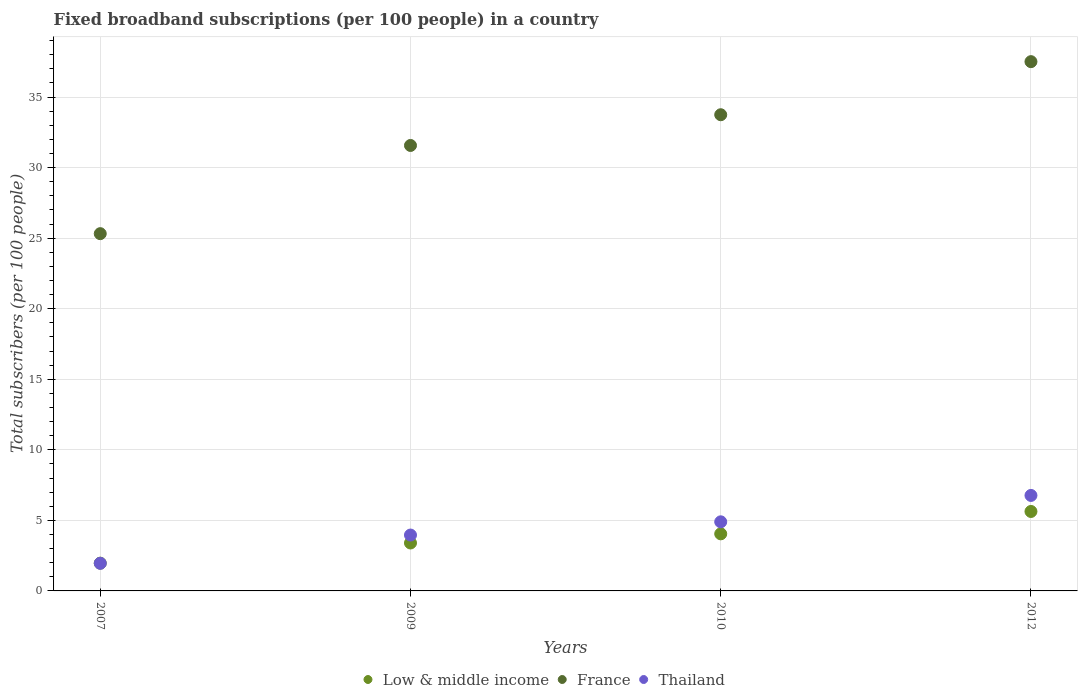What is the number of broadband subscriptions in Low & middle income in 2012?
Make the answer very short. 5.63. Across all years, what is the maximum number of broadband subscriptions in France?
Your response must be concise. 37.51. Across all years, what is the minimum number of broadband subscriptions in Thailand?
Make the answer very short. 1.96. In which year was the number of broadband subscriptions in Thailand maximum?
Keep it short and to the point. 2012. In which year was the number of broadband subscriptions in Low & middle income minimum?
Your response must be concise. 2007. What is the total number of broadband subscriptions in Thailand in the graph?
Make the answer very short. 17.58. What is the difference between the number of broadband subscriptions in Low & middle income in 2007 and that in 2010?
Offer a terse response. -2.08. What is the difference between the number of broadband subscriptions in Thailand in 2009 and the number of broadband subscriptions in France in 2012?
Offer a very short reply. -33.55. What is the average number of broadband subscriptions in Thailand per year?
Give a very brief answer. 4.4. In the year 2010, what is the difference between the number of broadband subscriptions in Thailand and number of broadband subscriptions in Low & middle income?
Provide a short and direct response. 0.85. In how many years, is the number of broadband subscriptions in France greater than 37?
Offer a very short reply. 1. What is the ratio of the number of broadband subscriptions in France in 2007 to that in 2012?
Ensure brevity in your answer.  0.68. Is the difference between the number of broadband subscriptions in Thailand in 2007 and 2009 greater than the difference between the number of broadband subscriptions in Low & middle income in 2007 and 2009?
Ensure brevity in your answer.  No. What is the difference between the highest and the second highest number of broadband subscriptions in France?
Offer a terse response. 3.76. What is the difference between the highest and the lowest number of broadband subscriptions in France?
Ensure brevity in your answer.  12.19. Is the sum of the number of broadband subscriptions in Thailand in 2009 and 2012 greater than the maximum number of broadband subscriptions in Low & middle income across all years?
Offer a terse response. Yes. Is it the case that in every year, the sum of the number of broadband subscriptions in Low & middle income and number of broadband subscriptions in France  is greater than the number of broadband subscriptions in Thailand?
Ensure brevity in your answer.  Yes. Does the number of broadband subscriptions in Low & middle income monotonically increase over the years?
Keep it short and to the point. Yes. Are the values on the major ticks of Y-axis written in scientific E-notation?
Ensure brevity in your answer.  No. Does the graph contain any zero values?
Your response must be concise. No. Does the graph contain grids?
Offer a very short reply. Yes. Where does the legend appear in the graph?
Provide a succinct answer. Bottom center. How are the legend labels stacked?
Provide a short and direct response. Horizontal. What is the title of the graph?
Ensure brevity in your answer.  Fixed broadband subscriptions (per 100 people) in a country. Does "Cote d'Ivoire" appear as one of the legend labels in the graph?
Provide a short and direct response. No. What is the label or title of the X-axis?
Offer a terse response. Years. What is the label or title of the Y-axis?
Offer a very short reply. Total subscribers (per 100 people). What is the Total subscribers (per 100 people) of Low & middle income in 2007?
Your answer should be compact. 1.97. What is the Total subscribers (per 100 people) in France in 2007?
Offer a very short reply. 25.32. What is the Total subscribers (per 100 people) of Thailand in 2007?
Provide a succinct answer. 1.96. What is the Total subscribers (per 100 people) of Low & middle income in 2009?
Give a very brief answer. 3.4. What is the Total subscribers (per 100 people) of France in 2009?
Give a very brief answer. 31.57. What is the Total subscribers (per 100 people) of Thailand in 2009?
Provide a short and direct response. 3.96. What is the Total subscribers (per 100 people) of Low & middle income in 2010?
Provide a succinct answer. 4.05. What is the Total subscribers (per 100 people) of France in 2010?
Provide a short and direct response. 33.74. What is the Total subscribers (per 100 people) in Thailand in 2010?
Make the answer very short. 4.9. What is the Total subscribers (per 100 people) of Low & middle income in 2012?
Your answer should be compact. 5.63. What is the Total subscribers (per 100 people) of France in 2012?
Keep it short and to the point. 37.51. What is the Total subscribers (per 100 people) in Thailand in 2012?
Your answer should be compact. 6.77. Across all years, what is the maximum Total subscribers (per 100 people) of Low & middle income?
Your answer should be compact. 5.63. Across all years, what is the maximum Total subscribers (per 100 people) in France?
Offer a very short reply. 37.51. Across all years, what is the maximum Total subscribers (per 100 people) in Thailand?
Provide a short and direct response. 6.77. Across all years, what is the minimum Total subscribers (per 100 people) of Low & middle income?
Offer a terse response. 1.97. Across all years, what is the minimum Total subscribers (per 100 people) of France?
Keep it short and to the point. 25.32. Across all years, what is the minimum Total subscribers (per 100 people) in Thailand?
Offer a very short reply. 1.96. What is the total Total subscribers (per 100 people) of Low & middle income in the graph?
Make the answer very short. 15.04. What is the total Total subscribers (per 100 people) in France in the graph?
Provide a short and direct response. 128.13. What is the total Total subscribers (per 100 people) in Thailand in the graph?
Your answer should be very brief. 17.58. What is the difference between the Total subscribers (per 100 people) of Low & middle income in 2007 and that in 2009?
Offer a terse response. -1.43. What is the difference between the Total subscribers (per 100 people) in France in 2007 and that in 2009?
Ensure brevity in your answer.  -6.25. What is the difference between the Total subscribers (per 100 people) in Thailand in 2007 and that in 2009?
Keep it short and to the point. -2. What is the difference between the Total subscribers (per 100 people) of Low & middle income in 2007 and that in 2010?
Give a very brief answer. -2.08. What is the difference between the Total subscribers (per 100 people) of France in 2007 and that in 2010?
Give a very brief answer. -8.43. What is the difference between the Total subscribers (per 100 people) of Thailand in 2007 and that in 2010?
Keep it short and to the point. -2.94. What is the difference between the Total subscribers (per 100 people) in Low & middle income in 2007 and that in 2012?
Offer a very short reply. -3.66. What is the difference between the Total subscribers (per 100 people) in France in 2007 and that in 2012?
Ensure brevity in your answer.  -12.19. What is the difference between the Total subscribers (per 100 people) in Thailand in 2007 and that in 2012?
Your answer should be compact. -4.81. What is the difference between the Total subscribers (per 100 people) in Low & middle income in 2009 and that in 2010?
Offer a very short reply. -0.65. What is the difference between the Total subscribers (per 100 people) in France in 2009 and that in 2010?
Provide a short and direct response. -2.18. What is the difference between the Total subscribers (per 100 people) of Thailand in 2009 and that in 2010?
Your answer should be very brief. -0.94. What is the difference between the Total subscribers (per 100 people) in Low & middle income in 2009 and that in 2012?
Keep it short and to the point. -2.23. What is the difference between the Total subscribers (per 100 people) in France in 2009 and that in 2012?
Your answer should be very brief. -5.94. What is the difference between the Total subscribers (per 100 people) of Thailand in 2009 and that in 2012?
Your answer should be very brief. -2.81. What is the difference between the Total subscribers (per 100 people) of Low & middle income in 2010 and that in 2012?
Your answer should be compact. -1.58. What is the difference between the Total subscribers (per 100 people) of France in 2010 and that in 2012?
Your response must be concise. -3.76. What is the difference between the Total subscribers (per 100 people) in Thailand in 2010 and that in 2012?
Provide a short and direct response. -1.87. What is the difference between the Total subscribers (per 100 people) of Low & middle income in 2007 and the Total subscribers (per 100 people) of France in 2009?
Ensure brevity in your answer.  -29.6. What is the difference between the Total subscribers (per 100 people) in Low & middle income in 2007 and the Total subscribers (per 100 people) in Thailand in 2009?
Provide a succinct answer. -1.99. What is the difference between the Total subscribers (per 100 people) of France in 2007 and the Total subscribers (per 100 people) of Thailand in 2009?
Make the answer very short. 21.36. What is the difference between the Total subscribers (per 100 people) of Low & middle income in 2007 and the Total subscribers (per 100 people) of France in 2010?
Your answer should be very brief. -31.78. What is the difference between the Total subscribers (per 100 people) in Low & middle income in 2007 and the Total subscribers (per 100 people) in Thailand in 2010?
Offer a terse response. -2.93. What is the difference between the Total subscribers (per 100 people) in France in 2007 and the Total subscribers (per 100 people) in Thailand in 2010?
Provide a succinct answer. 20.42. What is the difference between the Total subscribers (per 100 people) of Low & middle income in 2007 and the Total subscribers (per 100 people) of France in 2012?
Provide a succinct answer. -35.54. What is the difference between the Total subscribers (per 100 people) of Low & middle income in 2007 and the Total subscribers (per 100 people) of Thailand in 2012?
Offer a very short reply. -4.8. What is the difference between the Total subscribers (per 100 people) of France in 2007 and the Total subscribers (per 100 people) of Thailand in 2012?
Give a very brief answer. 18.55. What is the difference between the Total subscribers (per 100 people) of Low & middle income in 2009 and the Total subscribers (per 100 people) of France in 2010?
Your answer should be compact. -30.35. What is the difference between the Total subscribers (per 100 people) in Low & middle income in 2009 and the Total subscribers (per 100 people) in Thailand in 2010?
Offer a terse response. -1.5. What is the difference between the Total subscribers (per 100 people) of France in 2009 and the Total subscribers (per 100 people) of Thailand in 2010?
Your answer should be compact. 26.67. What is the difference between the Total subscribers (per 100 people) in Low & middle income in 2009 and the Total subscribers (per 100 people) in France in 2012?
Make the answer very short. -34.11. What is the difference between the Total subscribers (per 100 people) of Low & middle income in 2009 and the Total subscribers (per 100 people) of Thailand in 2012?
Make the answer very short. -3.37. What is the difference between the Total subscribers (per 100 people) of France in 2009 and the Total subscribers (per 100 people) of Thailand in 2012?
Keep it short and to the point. 24.8. What is the difference between the Total subscribers (per 100 people) of Low & middle income in 2010 and the Total subscribers (per 100 people) of France in 2012?
Make the answer very short. -33.46. What is the difference between the Total subscribers (per 100 people) of Low & middle income in 2010 and the Total subscribers (per 100 people) of Thailand in 2012?
Keep it short and to the point. -2.72. What is the difference between the Total subscribers (per 100 people) in France in 2010 and the Total subscribers (per 100 people) in Thailand in 2012?
Make the answer very short. 26.98. What is the average Total subscribers (per 100 people) in Low & middle income per year?
Keep it short and to the point. 3.76. What is the average Total subscribers (per 100 people) in France per year?
Ensure brevity in your answer.  32.03. What is the average Total subscribers (per 100 people) of Thailand per year?
Provide a short and direct response. 4.4. In the year 2007, what is the difference between the Total subscribers (per 100 people) of Low & middle income and Total subscribers (per 100 people) of France?
Give a very brief answer. -23.35. In the year 2007, what is the difference between the Total subscribers (per 100 people) of Low & middle income and Total subscribers (per 100 people) of Thailand?
Your response must be concise. 0.01. In the year 2007, what is the difference between the Total subscribers (per 100 people) in France and Total subscribers (per 100 people) in Thailand?
Give a very brief answer. 23.36. In the year 2009, what is the difference between the Total subscribers (per 100 people) in Low & middle income and Total subscribers (per 100 people) in France?
Your response must be concise. -28.17. In the year 2009, what is the difference between the Total subscribers (per 100 people) in Low & middle income and Total subscribers (per 100 people) in Thailand?
Give a very brief answer. -0.56. In the year 2009, what is the difference between the Total subscribers (per 100 people) of France and Total subscribers (per 100 people) of Thailand?
Give a very brief answer. 27.61. In the year 2010, what is the difference between the Total subscribers (per 100 people) of Low & middle income and Total subscribers (per 100 people) of France?
Provide a short and direct response. -29.7. In the year 2010, what is the difference between the Total subscribers (per 100 people) in Low & middle income and Total subscribers (per 100 people) in Thailand?
Offer a terse response. -0.85. In the year 2010, what is the difference between the Total subscribers (per 100 people) of France and Total subscribers (per 100 people) of Thailand?
Your answer should be compact. 28.85. In the year 2012, what is the difference between the Total subscribers (per 100 people) of Low & middle income and Total subscribers (per 100 people) of France?
Ensure brevity in your answer.  -31.88. In the year 2012, what is the difference between the Total subscribers (per 100 people) in Low & middle income and Total subscribers (per 100 people) in Thailand?
Offer a very short reply. -1.14. In the year 2012, what is the difference between the Total subscribers (per 100 people) in France and Total subscribers (per 100 people) in Thailand?
Your answer should be very brief. 30.74. What is the ratio of the Total subscribers (per 100 people) in Low & middle income in 2007 to that in 2009?
Keep it short and to the point. 0.58. What is the ratio of the Total subscribers (per 100 people) in France in 2007 to that in 2009?
Your answer should be compact. 0.8. What is the ratio of the Total subscribers (per 100 people) of Thailand in 2007 to that in 2009?
Your answer should be very brief. 0.49. What is the ratio of the Total subscribers (per 100 people) in Low & middle income in 2007 to that in 2010?
Your answer should be compact. 0.49. What is the ratio of the Total subscribers (per 100 people) of France in 2007 to that in 2010?
Provide a succinct answer. 0.75. What is the ratio of the Total subscribers (per 100 people) in Thailand in 2007 to that in 2010?
Give a very brief answer. 0.4. What is the ratio of the Total subscribers (per 100 people) in Low & middle income in 2007 to that in 2012?
Provide a succinct answer. 0.35. What is the ratio of the Total subscribers (per 100 people) in France in 2007 to that in 2012?
Ensure brevity in your answer.  0.68. What is the ratio of the Total subscribers (per 100 people) of Thailand in 2007 to that in 2012?
Make the answer very short. 0.29. What is the ratio of the Total subscribers (per 100 people) in Low & middle income in 2009 to that in 2010?
Offer a terse response. 0.84. What is the ratio of the Total subscribers (per 100 people) of France in 2009 to that in 2010?
Keep it short and to the point. 0.94. What is the ratio of the Total subscribers (per 100 people) in Thailand in 2009 to that in 2010?
Offer a very short reply. 0.81. What is the ratio of the Total subscribers (per 100 people) in Low & middle income in 2009 to that in 2012?
Provide a succinct answer. 0.6. What is the ratio of the Total subscribers (per 100 people) of France in 2009 to that in 2012?
Your answer should be very brief. 0.84. What is the ratio of the Total subscribers (per 100 people) of Thailand in 2009 to that in 2012?
Keep it short and to the point. 0.59. What is the ratio of the Total subscribers (per 100 people) of Low & middle income in 2010 to that in 2012?
Make the answer very short. 0.72. What is the ratio of the Total subscribers (per 100 people) in France in 2010 to that in 2012?
Ensure brevity in your answer.  0.9. What is the ratio of the Total subscribers (per 100 people) of Thailand in 2010 to that in 2012?
Keep it short and to the point. 0.72. What is the difference between the highest and the second highest Total subscribers (per 100 people) in Low & middle income?
Ensure brevity in your answer.  1.58. What is the difference between the highest and the second highest Total subscribers (per 100 people) of France?
Provide a short and direct response. 3.76. What is the difference between the highest and the second highest Total subscribers (per 100 people) of Thailand?
Your response must be concise. 1.87. What is the difference between the highest and the lowest Total subscribers (per 100 people) of Low & middle income?
Offer a terse response. 3.66. What is the difference between the highest and the lowest Total subscribers (per 100 people) of France?
Offer a very short reply. 12.19. What is the difference between the highest and the lowest Total subscribers (per 100 people) of Thailand?
Give a very brief answer. 4.81. 